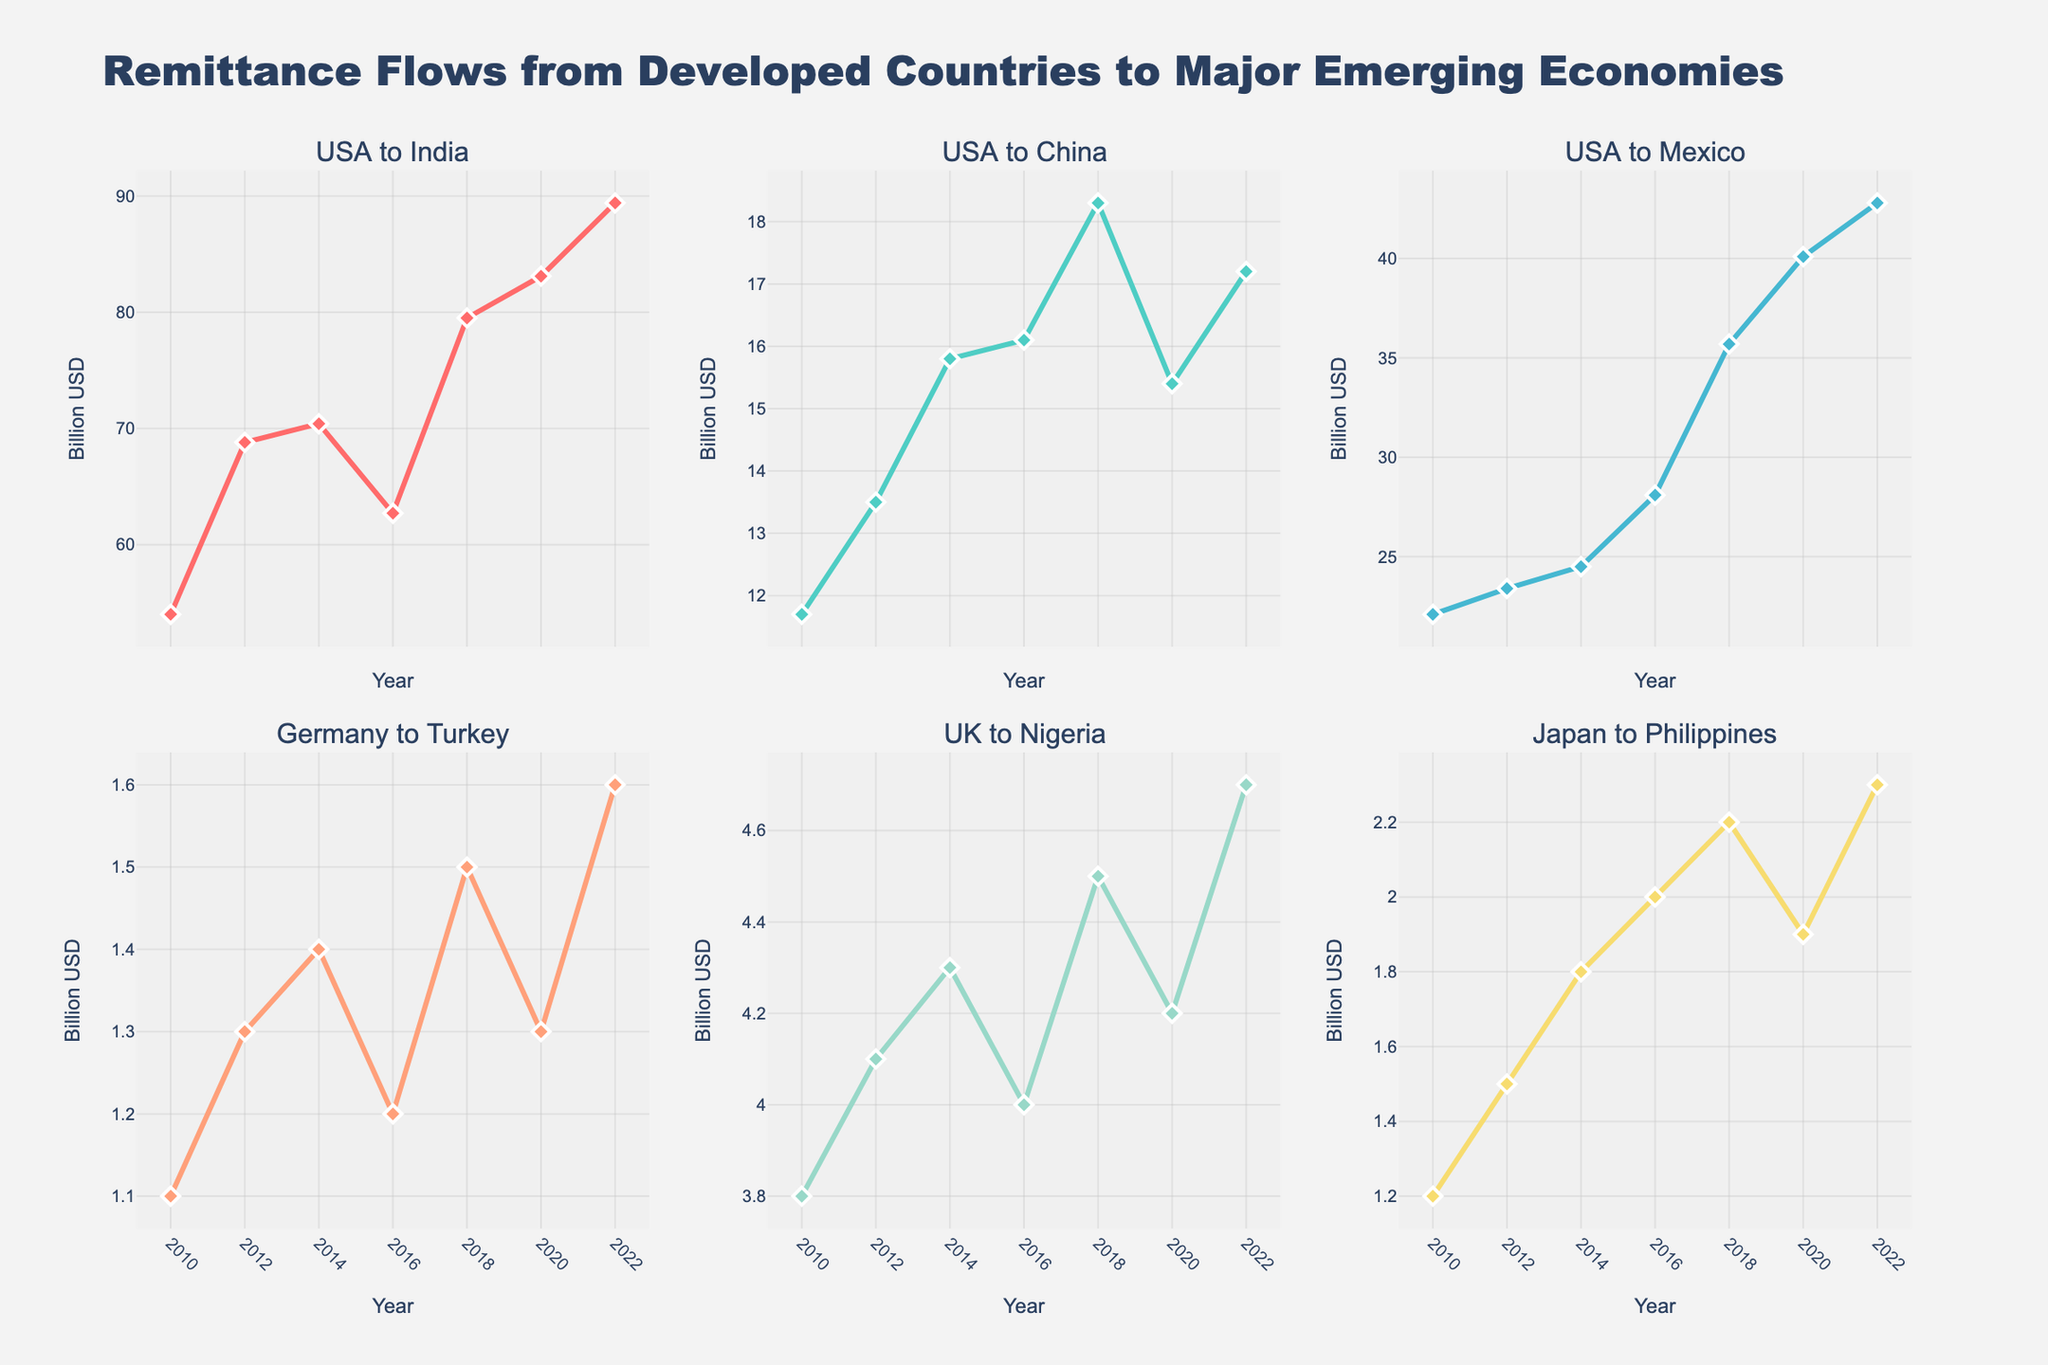What is the title of the figure? The title is located at the top of the figure and provides a summary of the chart's content. The title reads "Remittance Flows from Developed Countries to Major Emerging Economies".
Answer: "Remittance Flows from Developed Countries to Major Emerging Economies" Which country received the highest remittance from the USA in 2022? Look at the plot titles for each subplot. Locate the subplot for the USA to each country and find the 2022 data point. The subplot for "USA to India" shows the highest value in 2022.
Answer: India How did remittances from the USA to Mexico change from 2016 to 2018? Observe the subplot titled "USA to Mexico". Note the value in 2016, which is approximately 28.1 billion USD, and compare it to the value in 2018, which is approximately 35.7 billion USD. The remittances increased.
Answer: Increased What trend is observed in the remittance flows from Germany to Turkey from 2010 to 2022? Look at the subplot titled "Germany to Turkey". Examine the line from 2010 to 2022. Note that the values fluctuate without consistent growth or decline.
Answer: Fluctuated Compare the remittance trends from the UK to Nigeria and Japan to the Philippines from 2010 to 2022. Examine the subplots titled "UK to Nigeria" and "Japan to Philippines". Both trends show a general increase over time, but "Japan to Philippines" has a slightly higher growth rate compared to "UK to Nigeria".
Answer: Both increased; Japan to the Philippines grew slightly faster What was the difference in remittance flow from the USA to China between 2018 and 2020? Observe the subplot titled "USA to China". The value in 2018 was approximately 18.3 billion USD and in 2020 it was 15.4 billion USD. The difference is 18.3 - 15.4 = 2.9 billion USD.
Answer: 2.9 billion USD Which remittance flow showed the most consistent increase over the years? Review all subplots and identify the trend that shows the most consistency. The subplot for "USA to Mexico" shows a steadily increasing trend without major fluctuations.
Answer: USA to Mexico What is the overall trend for remittance flows from the USA to India from 2010 to 2022? Look at the subplot titled "USA to India". Over the years, the plot shows a general increasing trend from 54.0 billion USD in 2010 to 89.4 billion USD in 2022.
Answer: Increasing How do the remittance flows in 2020 from the USA to Mexico and the USA to India compare? Check the subplots for "USA to Mexico" and "USA to India" for the year 2020. "USA to Mexico" has 40.1 billion USD, and "USA to India" has 83.1 billion USD. "USA to India" is higher.
Answer: USA to India is higher Which remittance flow showed a decline between any two consecutive years? Examine each subplot for any two consecutive years where the value decreases. The subplot for "USA to China" shows a decline from 2018 (18.3 billion USD) to 2020 (15.4 billion USD).
Answer: USA to China (2018 to 2020) 